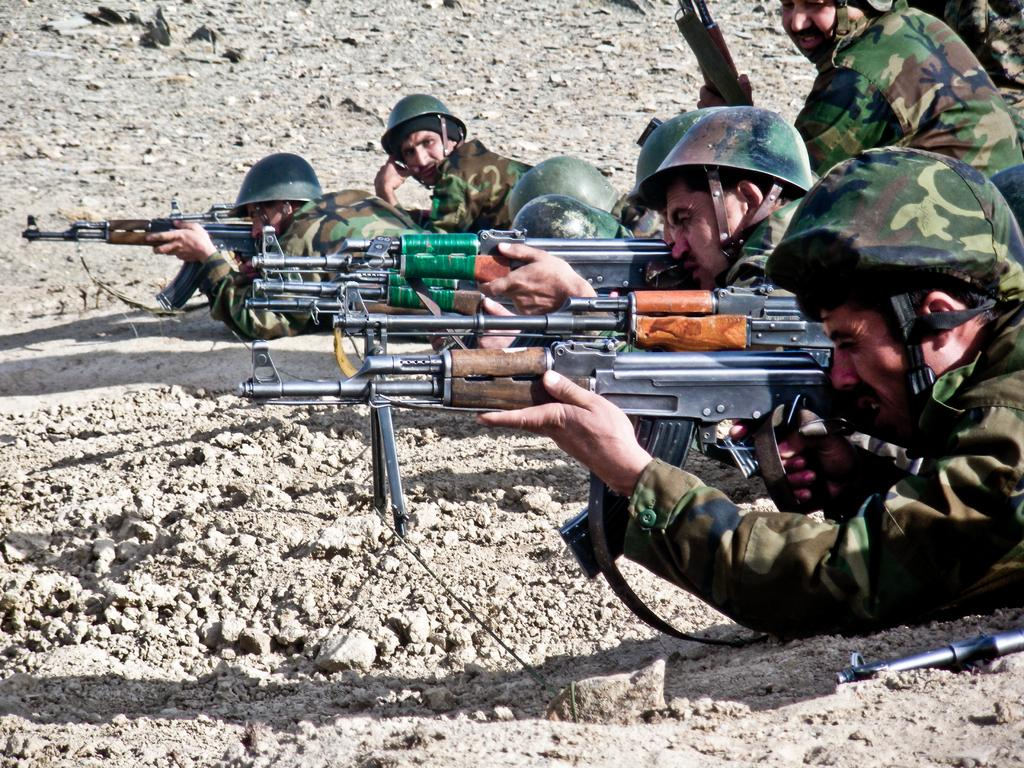What type of people can be seen in the image? There are soldiers in the image. Where are the soldiers located? The soldiers are on the ground. What are the soldiers holding in the image? The soldiers are holding guns. What type of tool is the soldier using to fix the crown in the image? There is no crown or tool present in the image; the soldiers are holding guns. 